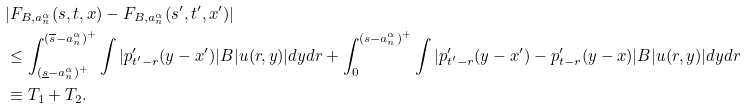Convert formula to latex. <formula><loc_0><loc_0><loc_500><loc_500>& | F _ { B , a _ { n } ^ { \alpha } } ( s , t , x ) - F _ { B , a _ { n } ^ { \alpha } } ( s ^ { \prime } , t ^ { \prime } , x ^ { \prime } ) | \\ & \leq \int _ { ( \underline { s } - a _ { n } ^ { \alpha } ) ^ { + } } ^ { ( \overline { s } - a _ { n } ^ { \alpha } ) ^ { + } } \int | p ^ { \prime } _ { t ^ { \prime } - r } ( y - x ^ { \prime } ) | B | u ( r , y ) | d y d r + \int _ { 0 } ^ { ( s - a _ { n } ^ { \alpha } ) ^ { + } } \int | p ^ { \prime } _ { t ^ { \prime } - r } ( y - x ^ { \prime } ) - p ^ { \prime } _ { t - r } ( y - x ) | B | u ( r , y ) | d y d r \\ & \equiv T _ { 1 } + T _ { 2 } .</formula> 